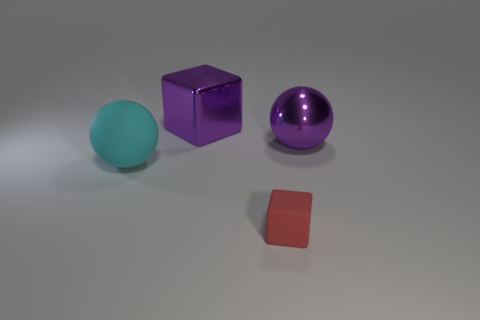Add 3 small objects. How many objects exist? 7 Add 4 red matte things. How many red matte things exist? 5 Subtract 0 brown spheres. How many objects are left? 4 Subtract all small things. Subtract all tiny red blocks. How many objects are left? 2 Add 4 large purple shiny blocks. How many large purple shiny blocks are left? 5 